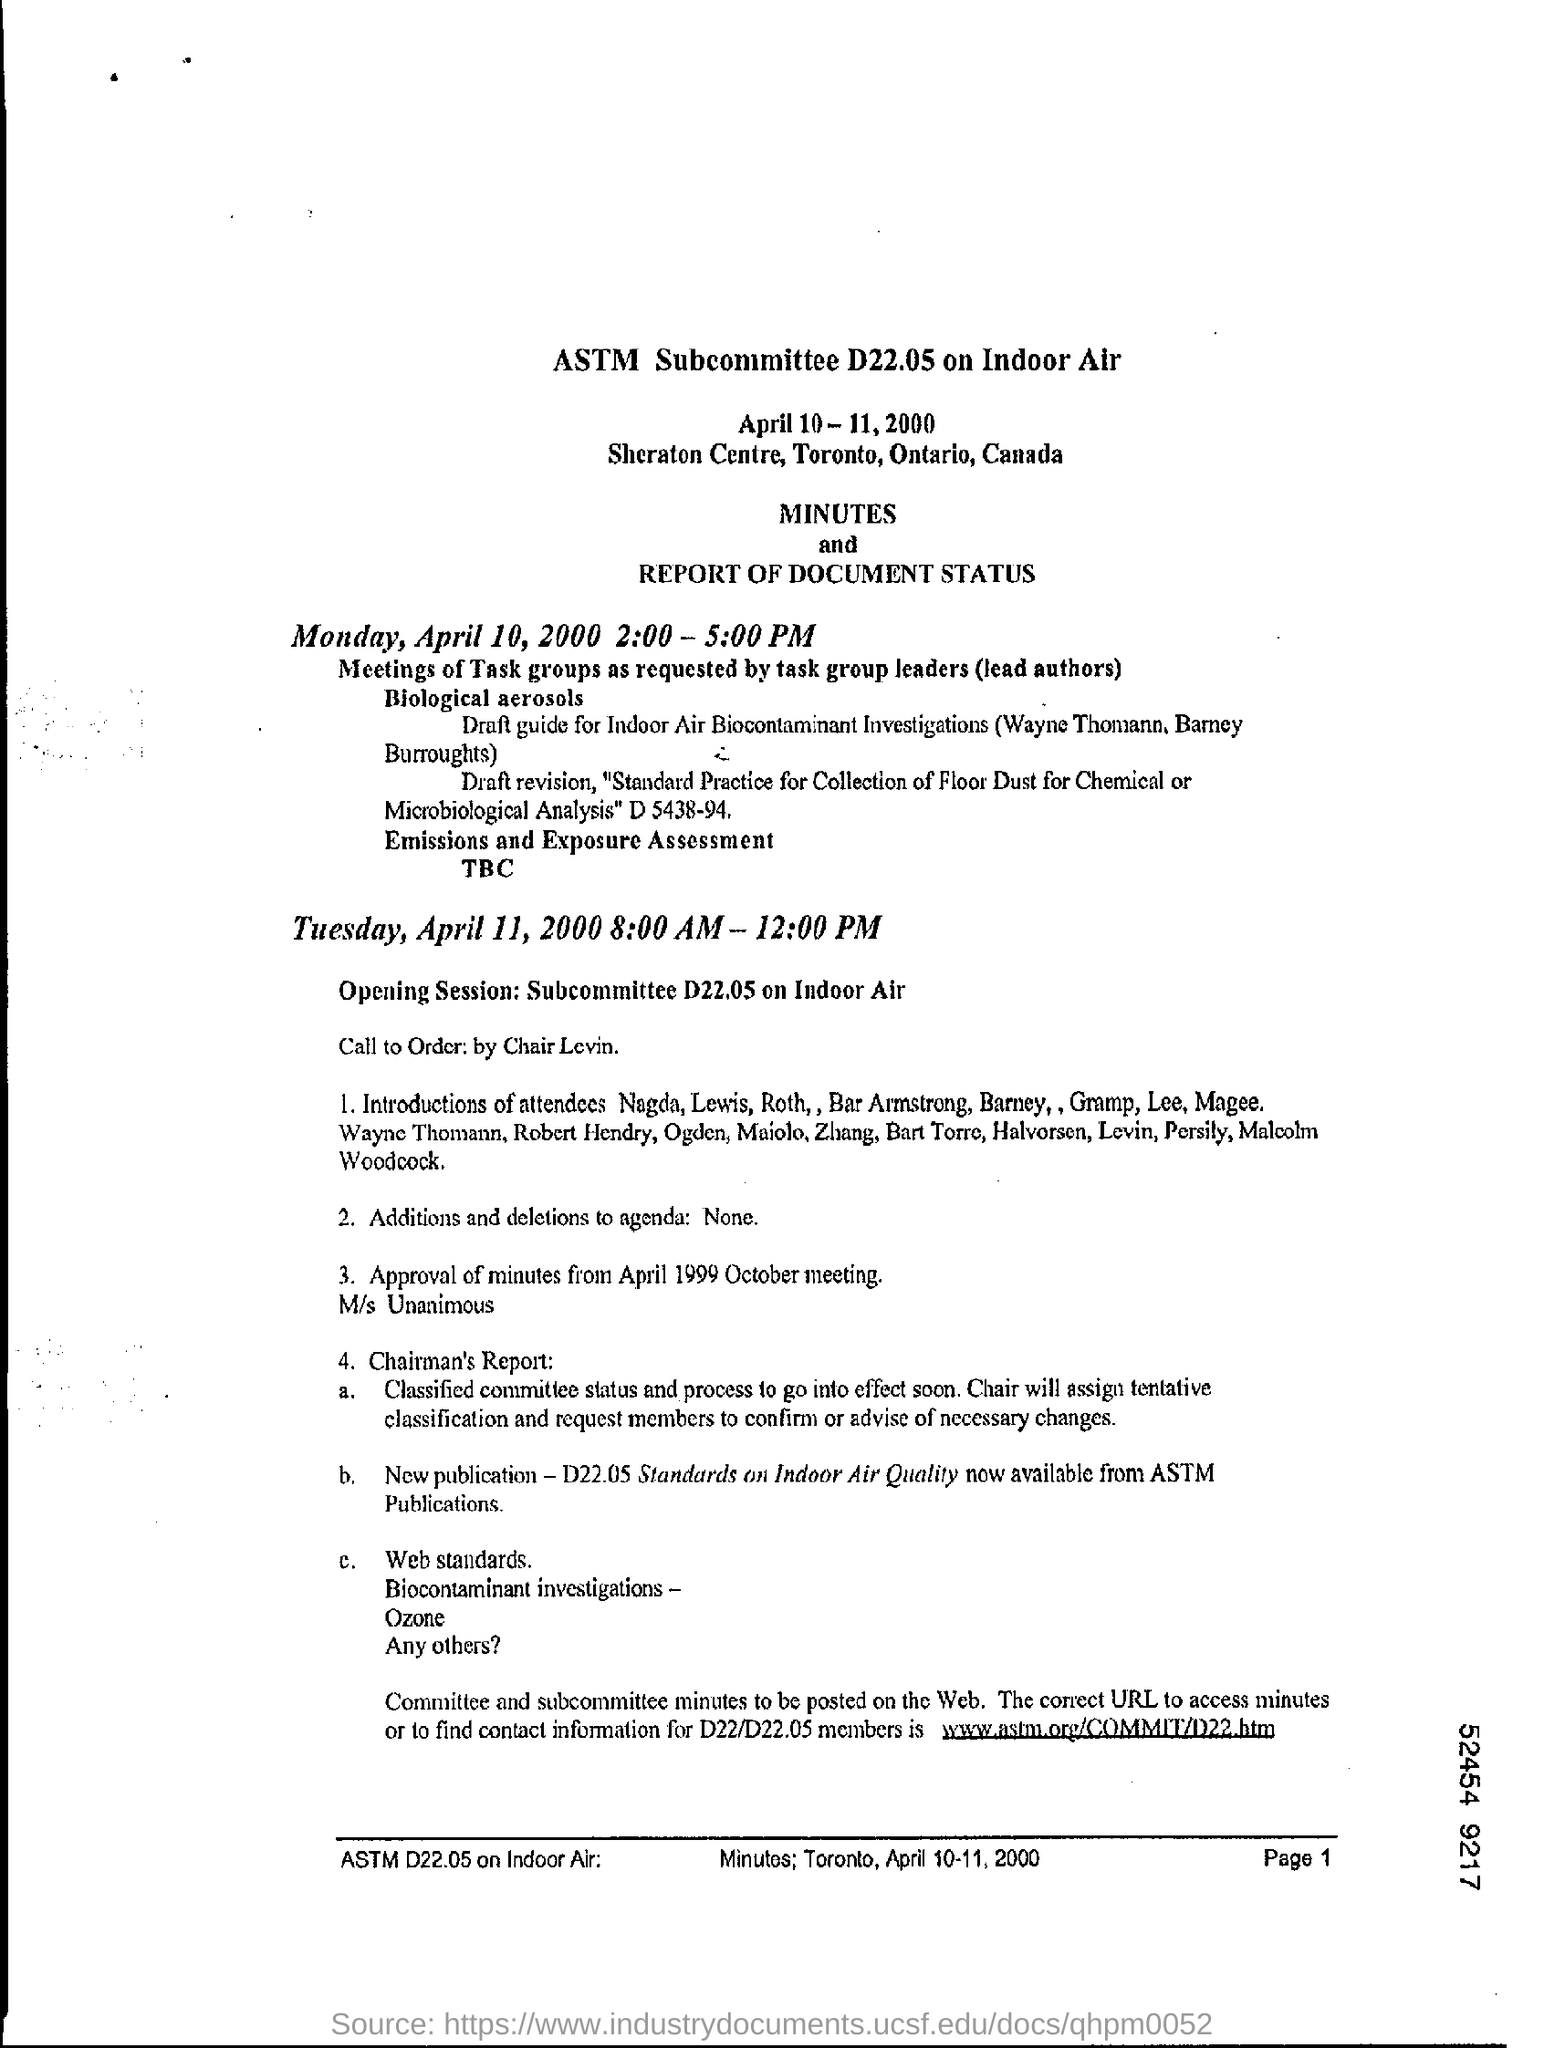Mention the page number at bottom right corner of the page ?
Provide a short and direct response. 1. What day of the week is april 10, 2000?
Your answer should be very brief. Monday. 